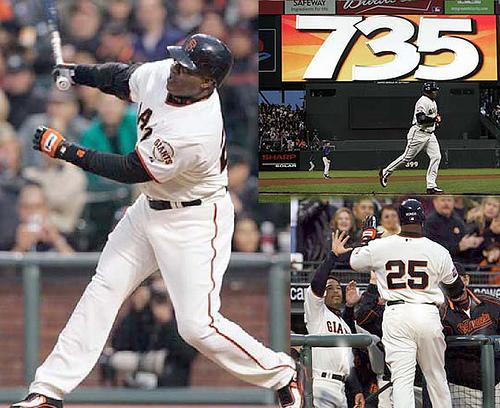What is the number in the top right corner?
Be succinct. 735. What sport is this person playing?
Give a very brief answer. Baseball. What does the number in the top right corner represent?
Keep it brief. Home runs. 